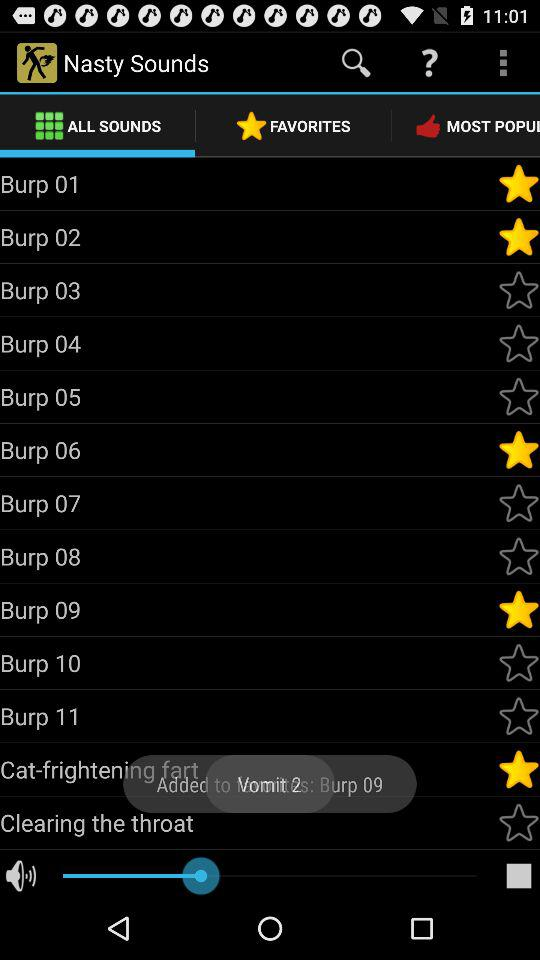Which tab is selected? The selected tab is "ALL SOUNDS". 